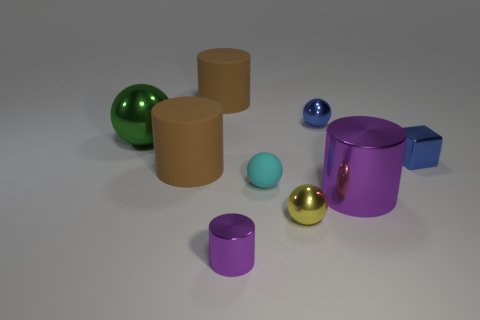Is the number of metal things right of the big green metal sphere the same as the number of cyan rubber balls?
Offer a very short reply. No. There is a metal thing that is both behind the block and right of the cyan matte ball; how big is it?
Provide a short and direct response. Small. Is there any other thing of the same color as the cube?
Provide a succinct answer. Yes. How big is the purple shiny thing that is left of the blue thing that is behind the large green sphere?
Offer a very short reply. Small. There is a metallic ball that is behind the small shiny cube and to the right of the big metal sphere; what color is it?
Your answer should be very brief. Blue. What number of other things are there of the same size as the cube?
Keep it short and to the point. 4. There is a blue metal cube; is its size the same as the brown matte cylinder behind the green sphere?
Make the answer very short. No. What is the color of the matte object that is the same size as the blue cube?
Ensure brevity in your answer.  Cyan. What is the size of the yellow metallic ball?
Make the answer very short. Small. Is the large brown cylinder in front of the block made of the same material as the tiny yellow thing?
Offer a terse response. No. 